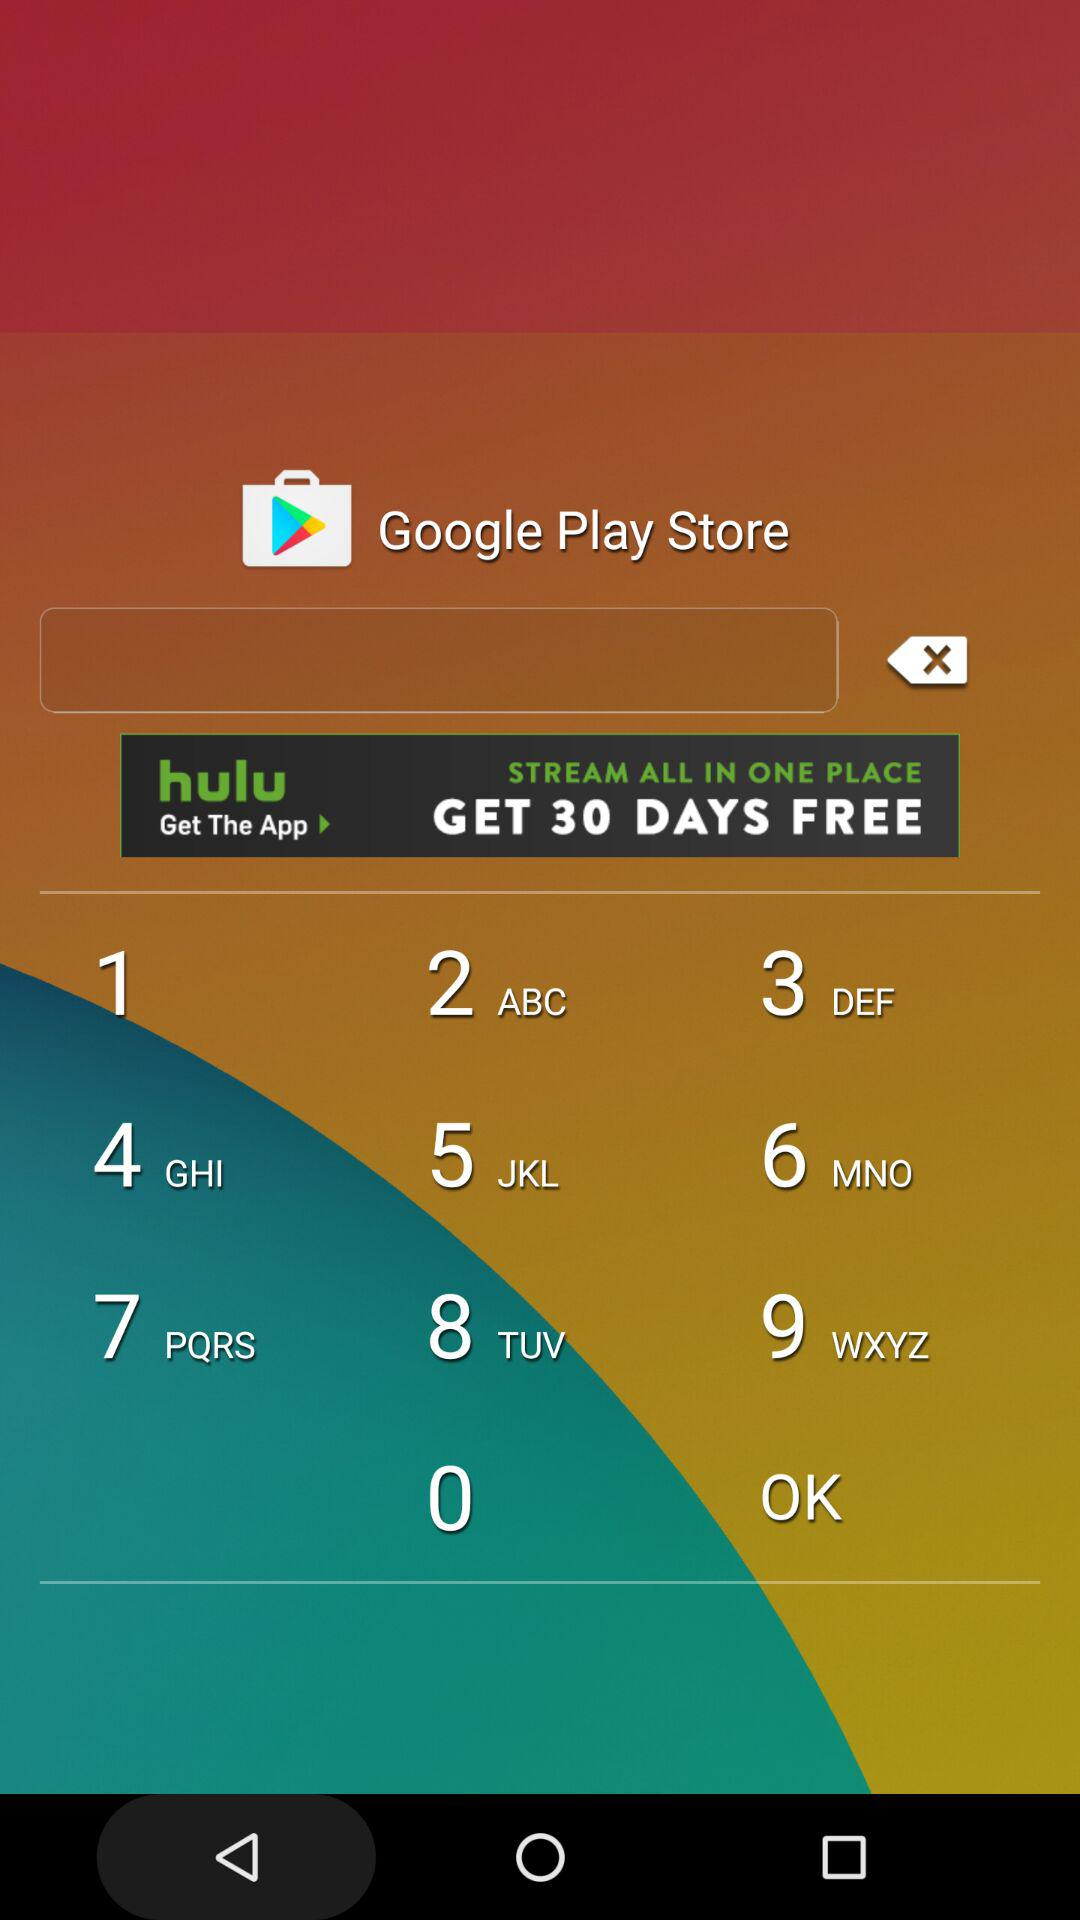How many furlongs are in the Maiden Claiming race? There are 6 furlongs in the Maiden Claiming race. 